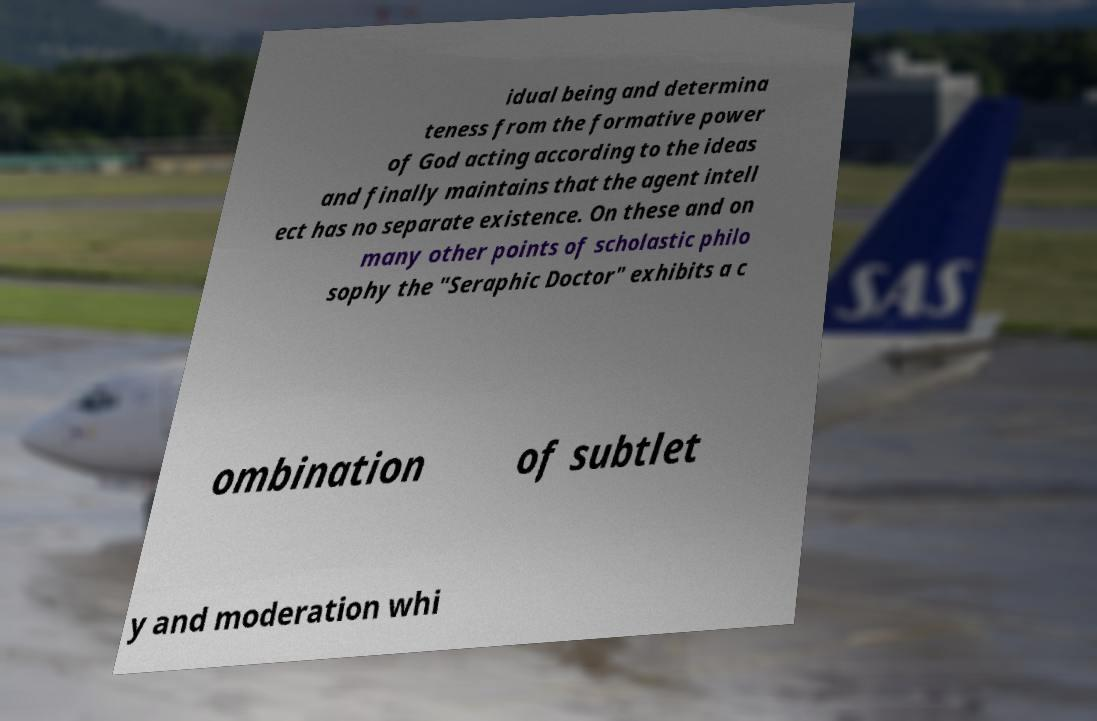For documentation purposes, I need the text within this image transcribed. Could you provide that? idual being and determina teness from the formative power of God acting according to the ideas and finally maintains that the agent intell ect has no separate existence. On these and on many other points of scholastic philo sophy the "Seraphic Doctor" exhibits a c ombination of subtlet y and moderation whi 